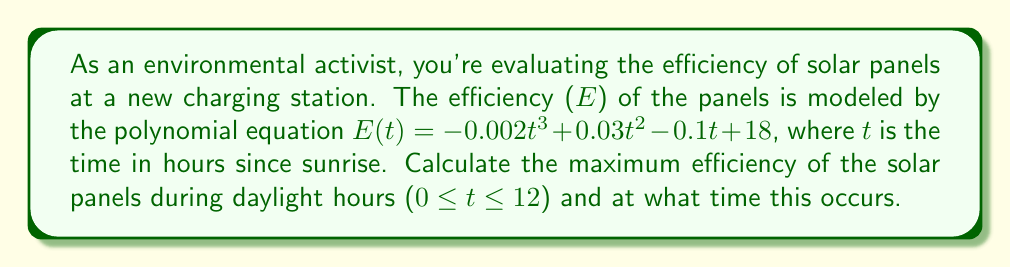What is the answer to this math problem? To find the maximum efficiency, we need to follow these steps:

1) First, we find the derivative of the efficiency function:
   $$E'(t) = -0.006t^2 + 0.06t - 0.1$$

2) Set the derivative equal to zero to find critical points:
   $$-0.006t^2 + 0.06t - 0.1 = 0$$

3) Solve this quadratic equation:
   $$t = \frac{-0.06 \pm \sqrt{0.06^2 - 4(-0.006)(-0.1)}}{2(-0.006)}$$
   $$t = \frac{-0.06 \pm \sqrt{0.0036 + 0.0024}}{-0.012}$$
   $$t = \frac{-0.06 \pm \sqrt{0.006}}{-0.012}$$
   $$t = \frac{-0.06 \pm 0.0775}{-0.012}$$

4) This gives us two solutions:
   $$t_1 = \frac{-0.06 + 0.0775}{-0.012} \approx 1.46$$
   $$t_2 = \frac{-0.06 - 0.0775}{-0.012} \approx 11.46$$

5) Since we're only considering 0 ≤ t ≤ 12, both critical points are valid.

6) Evaluate E(t) at t = 0, 1.46, 11.46, and 12:
   $$E(0) = 18$$
   $$E(1.46) \approx 18.22$$
   $$E(11.46) \approx 15.76$$
   $$E(12) = 15.6$$

7) The maximum value is approximately 18.22, occurring at t ≈ 1.46 hours after sunrise.
Answer: Maximum efficiency: 18.22%, Time: 1.46 hours after sunrise 